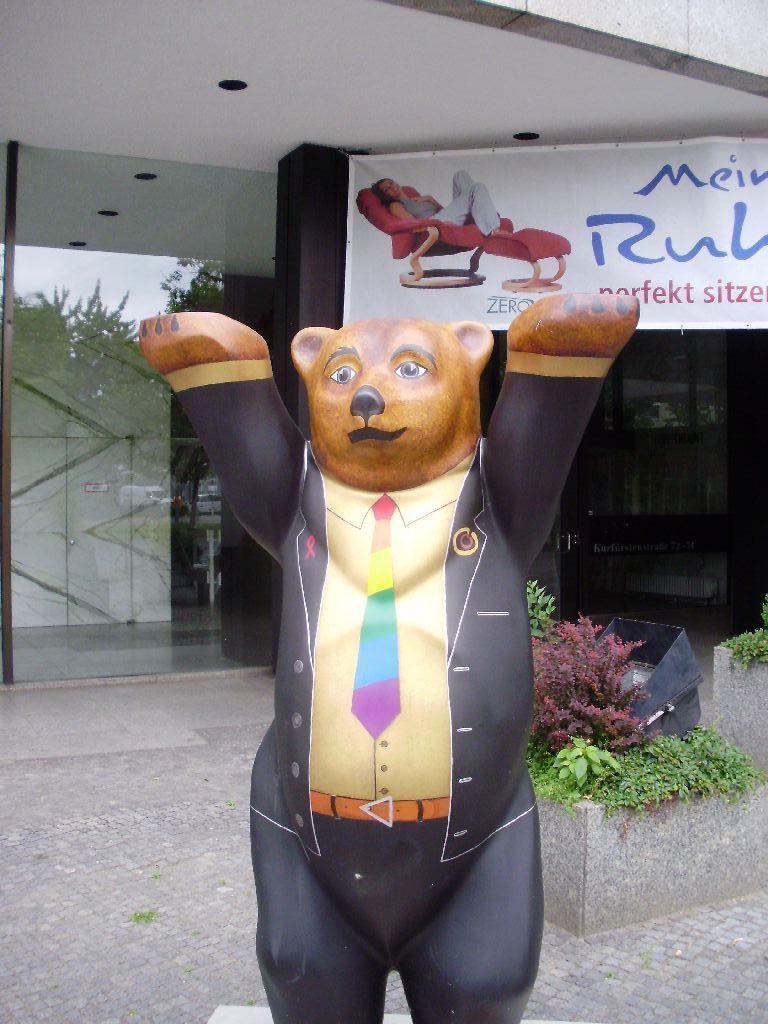Can you describe this image briefly? This image is taken outdoors. At the bottom of the image there is a floor. In the middle of the image there is a toy. In the background there is a building with a glass door and walls and there is a board with a text on it. On the right side of the image there are a few plants. 